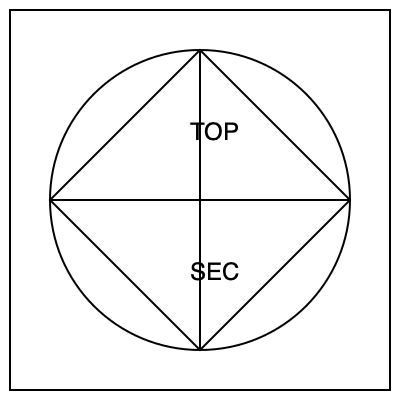If the security badge design shown above is rotated 90 degrees clockwise, which of the following statements is true?
A) The word "TOP" will be on the right side of the badge
B) The word "SEC" will be on the left side of the badge
C) The square will become a diamond shape
D) The circle will become an oval To solve this problem, let's follow these steps:

1. Visualize the 90-degree clockwise rotation:
   - The top of the badge will become the right side
   - The right side will become the bottom
   - The bottom will become the left side
   - The left side will become the top

2. Analyze each statement:
   A) The word "TOP" is currently at the top. After rotation, it will be on the right side. This is true.
   B) The word "SEC" is currently at the bottom. After rotation, it will be on the left side. This is true.
   C) The square is formed by connecting the midpoints of the circle. Rotating it will not change its shape; it will remain a square. This is false.
   D) The circle is symmetrical. Rotating it will not change its shape; it will remain a circle. This is false.

3. Identify the correct answer:
   Only statement A is true. The word "TOP" will indeed be on the right side of the badge after a 90-degree clockwise rotation.
Answer: A 